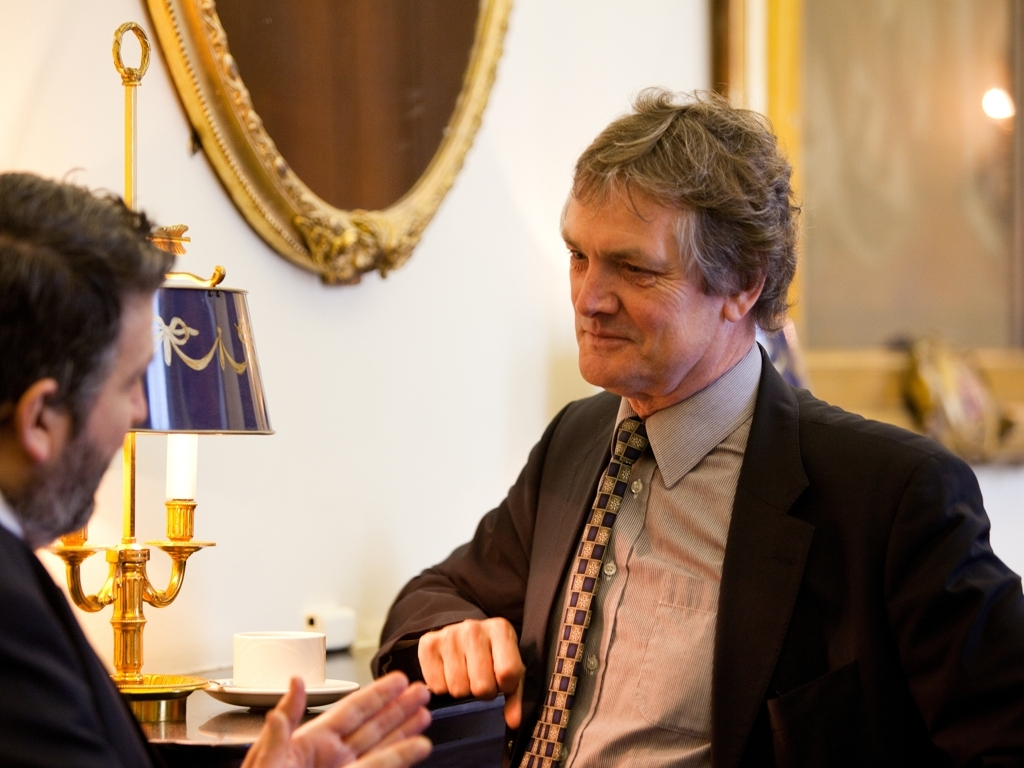What kind of atmosphere does the image evoke, and what elements contribute to that? The image evokes a formal and serious atmosphere. Elements contributing to that include the solemn expressions of the two individuals engaged in conversation, the elegant and traditional decor of the room with its classical furnishings and ornamented lamp, and the subdued lighting, which gives the scene a weighty, thoughtful ambiance. 